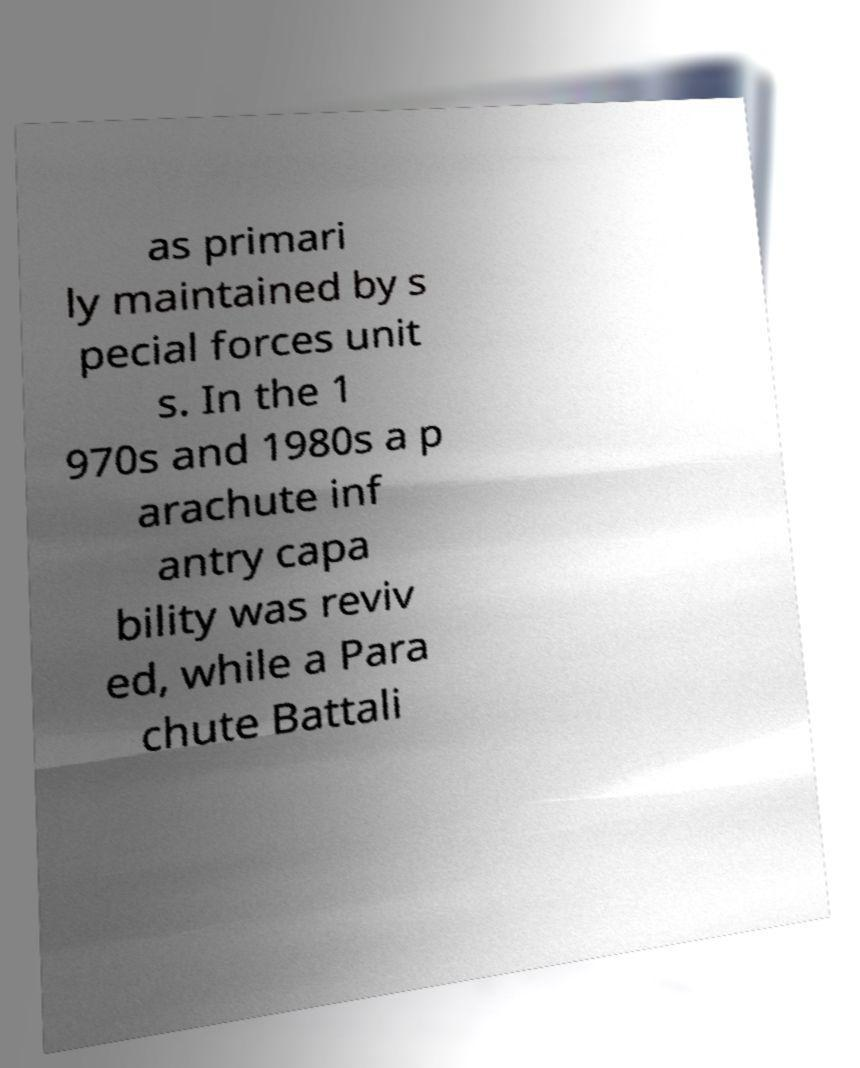There's text embedded in this image that I need extracted. Can you transcribe it verbatim? as primari ly maintained by s pecial forces unit s. In the 1 970s and 1980s a p arachute inf antry capa bility was reviv ed, while a Para chute Battali 